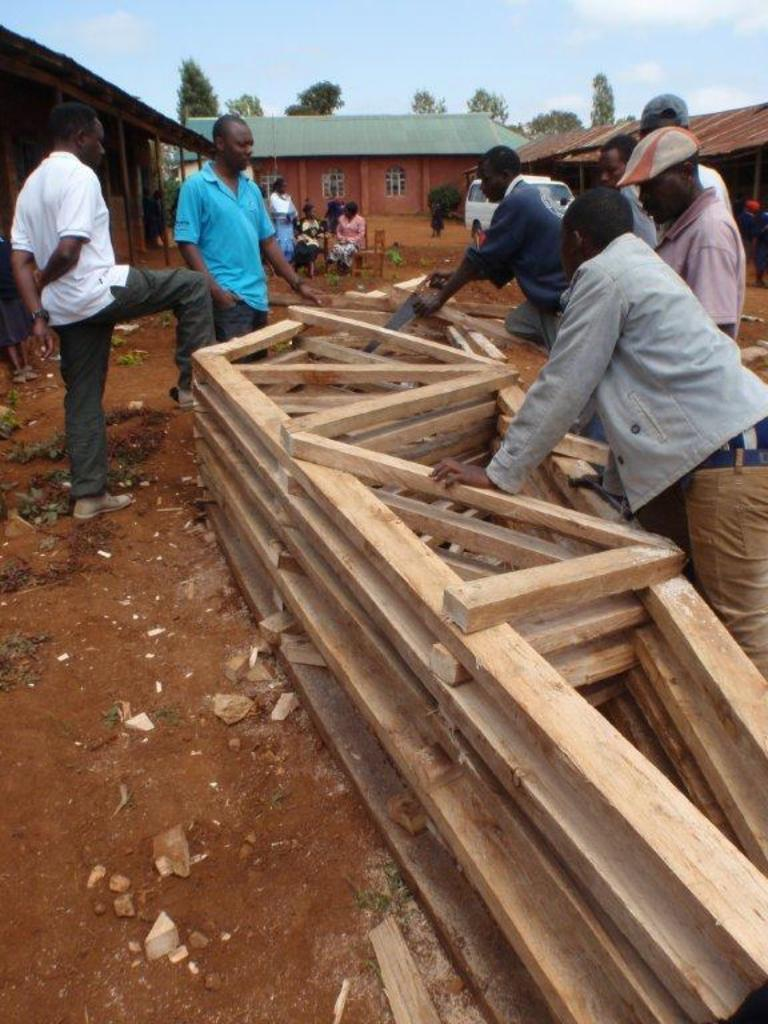Who or what can be seen in the image? There are people in the image. What activity are the people engaged in? The people are doing something with wood. What can be seen in the background of the image? There are trees and clouds in the sky in the background of the image. What type of music can be heard coming from the pocket in the image? There is no pocket or music present in the image. Can you describe the bee's role in the woodworking activity in the image? There are no bees present in the image, and they are not involved in the woodworking activity. 